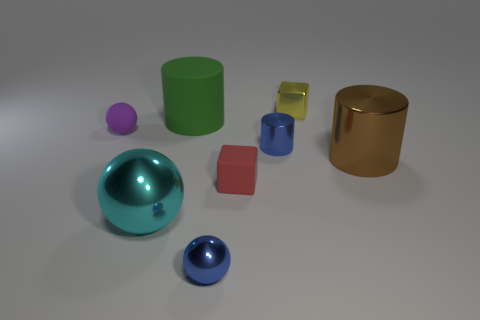Subtract 1 balls. How many balls are left? 2 Subtract all big cylinders. How many cylinders are left? 1 Add 1 tiny blue cylinders. How many objects exist? 9 Subtract all balls. How many objects are left? 5 Add 8 blue metal things. How many blue metal things exist? 10 Subtract 0 yellow cylinders. How many objects are left? 8 Subtract all big brown rubber things. Subtract all small cylinders. How many objects are left? 7 Add 3 brown things. How many brown things are left? 4 